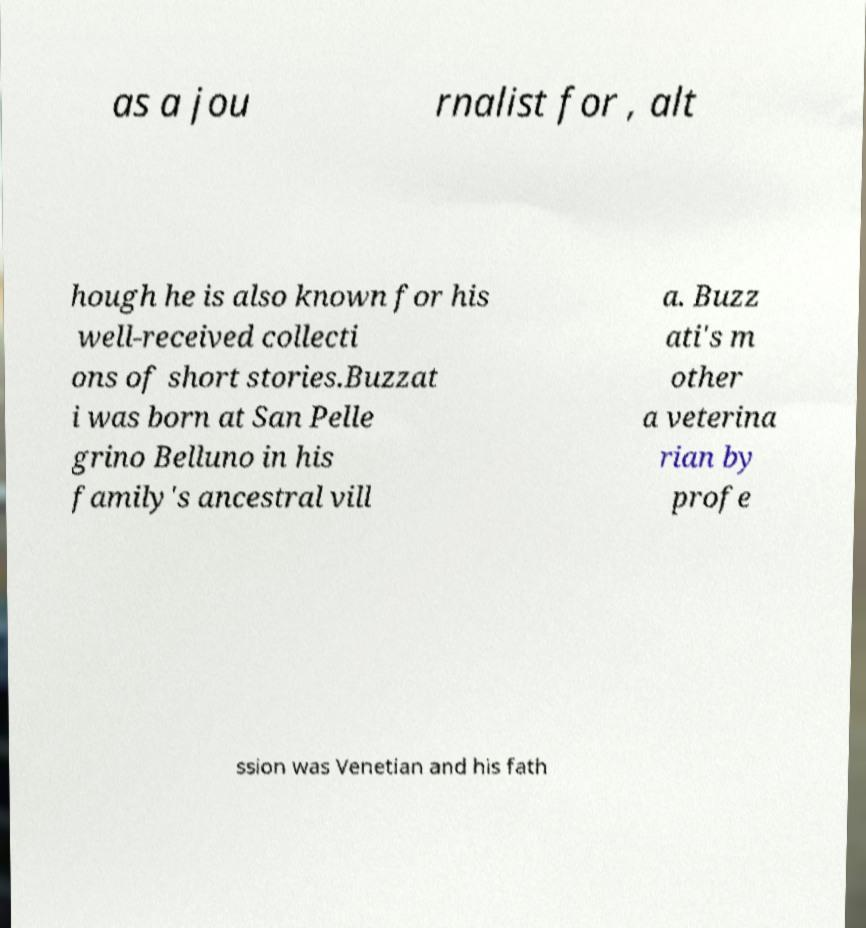Please read and relay the text visible in this image. What does it say? as a jou rnalist for , alt hough he is also known for his well-received collecti ons of short stories.Buzzat i was born at San Pelle grino Belluno in his family's ancestral vill a. Buzz ati's m other a veterina rian by profe ssion was Venetian and his fath 